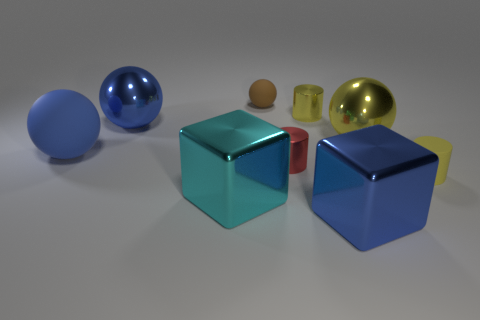Subtract all brown balls. How many balls are left? 3 Subtract all small yellow matte cylinders. How many cylinders are left? 2 Add 1 blue metal cubes. How many objects exist? 10 Subtract all green spheres. Subtract all cyan blocks. How many spheres are left? 4 Subtract all cylinders. How many objects are left? 6 Add 1 big rubber balls. How many big rubber balls exist? 2 Subtract 0 red cubes. How many objects are left? 9 Subtract all metallic balls. Subtract all cyan objects. How many objects are left? 6 Add 1 big yellow metallic objects. How many big yellow metallic objects are left? 2 